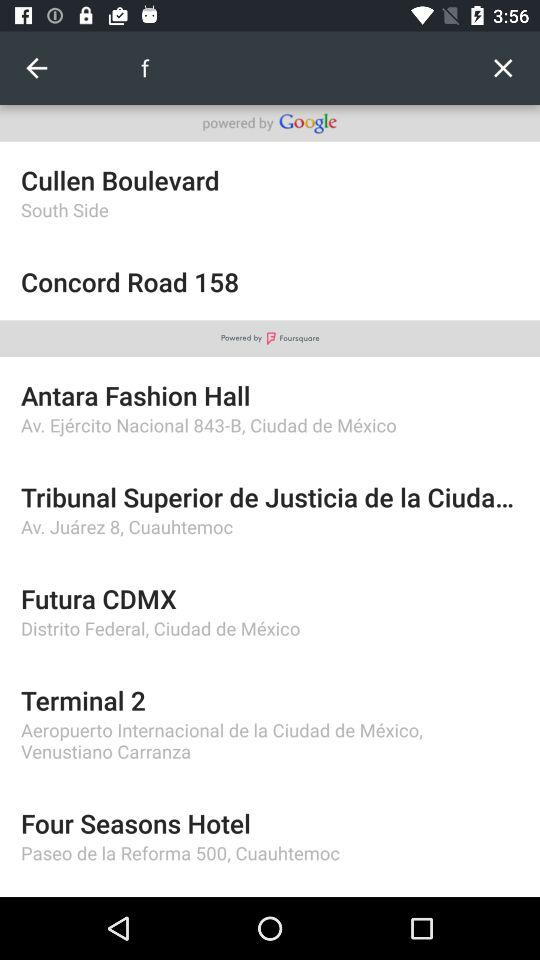What is the hotel's name? The hotel's name is "Four Seasons". 